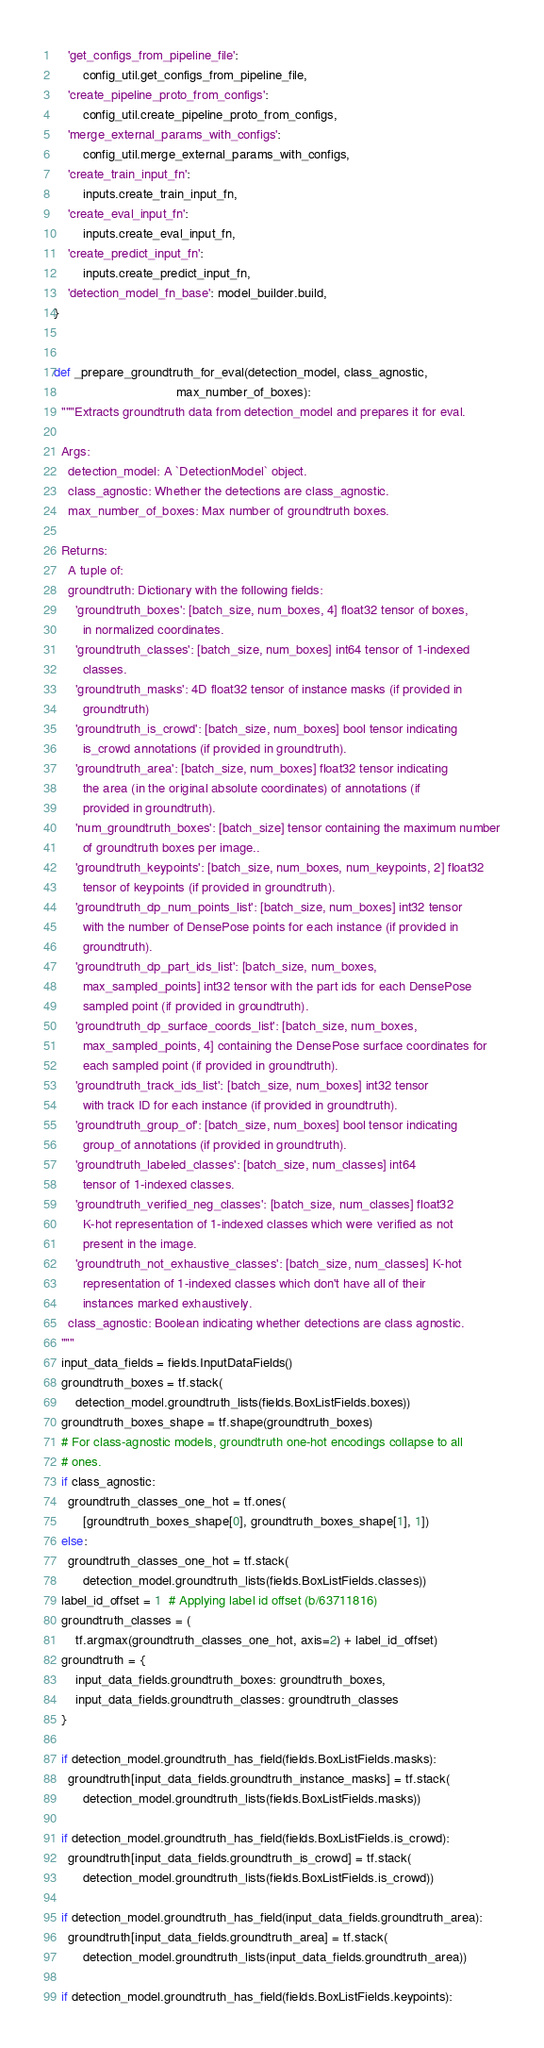Convert code to text. <code><loc_0><loc_0><loc_500><loc_500><_Python_>    'get_configs_from_pipeline_file':
        config_util.get_configs_from_pipeline_file,
    'create_pipeline_proto_from_configs':
        config_util.create_pipeline_proto_from_configs,
    'merge_external_params_with_configs':
        config_util.merge_external_params_with_configs,
    'create_train_input_fn':
        inputs.create_train_input_fn,
    'create_eval_input_fn':
        inputs.create_eval_input_fn,
    'create_predict_input_fn':
        inputs.create_predict_input_fn,
    'detection_model_fn_base': model_builder.build,
}


def _prepare_groundtruth_for_eval(detection_model, class_agnostic,
                                  max_number_of_boxes):
  """Extracts groundtruth data from detection_model and prepares it for eval.

  Args:
    detection_model: A `DetectionModel` object.
    class_agnostic: Whether the detections are class_agnostic.
    max_number_of_boxes: Max number of groundtruth boxes.

  Returns:
    A tuple of:
    groundtruth: Dictionary with the following fields:
      'groundtruth_boxes': [batch_size, num_boxes, 4] float32 tensor of boxes,
        in normalized coordinates.
      'groundtruth_classes': [batch_size, num_boxes] int64 tensor of 1-indexed
        classes.
      'groundtruth_masks': 4D float32 tensor of instance masks (if provided in
        groundtruth)
      'groundtruth_is_crowd': [batch_size, num_boxes] bool tensor indicating
        is_crowd annotations (if provided in groundtruth).
      'groundtruth_area': [batch_size, num_boxes] float32 tensor indicating
        the area (in the original absolute coordinates) of annotations (if
        provided in groundtruth).
      'num_groundtruth_boxes': [batch_size] tensor containing the maximum number
        of groundtruth boxes per image..
      'groundtruth_keypoints': [batch_size, num_boxes, num_keypoints, 2] float32
        tensor of keypoints (if provided in groundtruth).
      'groundtruth_dp_num_points_list': [batch_size, num_boxes] int32 tensor
        with the number of DensePose points for each instance (if provided in
        groundtruth).
      'groundtruth_dp_part_ids_list': [batch_size, num_boxes,
        max_sampled_points] int32 tensor with the part ids for each DensePose
        sampled point (if provided in groundtruth).
      'groundtruth_dp_surface_coords_list': [batch_size, num_boxes,
        max_sampled_points, 4] containing the DensePose surface coordinates for
        each sampled point (if provided in groundtruth).
      'groundtruth_track_ids_list': [batch_size, num_boxes] int32 tensor
        with track ID for each instance (if provided in groundtruth).
      'groundtruth_group_of': [batch_size, num_boxes] bool tensor indicating
        group_of annotations (if provided in groundtruth).
      'groundtruth_labeled_classes': [batch_size, num_classes] int64
        tensor of 1-indexed classes.
      'groundtruth_verified_neg_classes': [batch_size, num_classes] float32
        K-hot representation of 1-indexed classes which were verified as not
        present in the image.
      'groundtruth_not_exhaustive_classes': [batch_size, num_classes] K-hot
        representation of 1-indexed classes which don't have all of their
        instances marked exhaustively.
    class_agnostic: Boolean indicating whether detections are class agnostic.
  """
  input_data_fields = fields.InputDataFields()
  groundtruth_boxes = tf.stack(
      detection_model.groundtruth_lists(fields.BoxListFields.boxes))
  groundtruth_boxes_shape = tf.shape(groundtruth_boxes)
  # For class-agnostic models, groundtruth one-hot encodings collapse to all
  # ones.
  if class_agnostic:
    groundtruth_classes_one_hot = tf.ones(
        [groundtruth_boxes_shape[0], groundtruth_boxes_shape[1], 1])
  else:
    groundtruth_classes_one_hot = tf.stack(
        detection_model.groundtruth_lists(fields.BoxListFields.classes))
  label_id_offset = 1  # Applying label id offset (b/63711816)
  groundtruth_classes = (
      tf.argmax(groundtruth_classes_one_hot, axis=2) + label_id_offset)
  groundtruth = {
      input_data_fields.groundtruth_boxes: groundtruth_boxes,
      input_data_fields.groundtruth_classes: groundtruth_classes
  }

  if detection_model.groundtruth_has_field(fields.BoxListFields.masks):
    groundtruth[input_data_fields.groundtruth_instance_masks] = tf.stack(
        detection_model.groundtruth_lists(fields.BoxListFields.masks))

  if detection_model.groundtruth_has_field(fields.BoxListFields.is_crowd):
    groundtruth[input_data_fields.groundtruth_is_crowd] = tf.stack(
        detection_model.groundtruth_lists(fields.BoxListFields.is_crowd))

  if detection_model.groundtruth_has_field(input_data_fields.groundtruth_area):
    groundtruth[input_data_fields.groundtruth_area] = tf.stack(
        detection_model.groundtruth_lists(input_data_fields.groundtruth_area))

  if detection_model.groundtruth_has_field(fields.BoxListFields.keypoints):</code> 